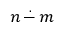Convert formula to latex. <formula><loc_0><loc_0><loc_500><loc_500>n \, { \stackrel { . } { - } } \, m</formula> 